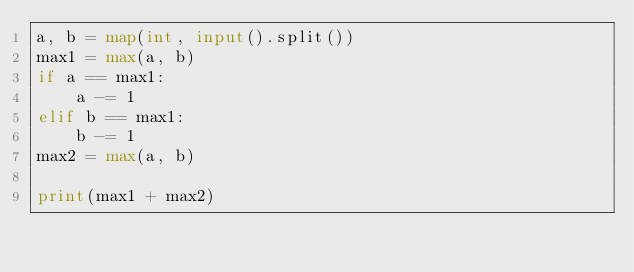<code> <loc_0><loc_0><loc_500><loc_500><_Python_>a, b = map(int, input().split())
max1 = max(a, b)
if a == max1:
    a -= 1
elif b == max1:
    b -= 1
max2 = max(a, b)

print(max1 + max2)</code> 